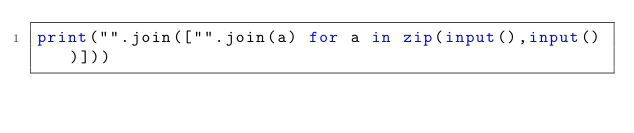Convert code to text. <code><loc_0><loc_0><loc_500><loc_500><_Python_>print("".join(["".join(a) for a in zip(input(),input())]))</code> 